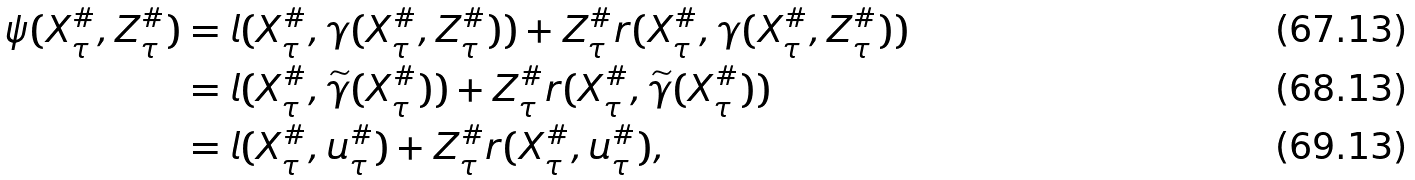<formula> <loc_0><loc_0><loc_500><loc_500>\psi ( X ^ { \# } _ { \tau } , Z ^ { \# } _ { \tau } ) & = l ( X ^ { \# } _ { \tau } , \gamma ( X ^ { \# } _ { \tau } , Z ^ { \# } _ { \tau } ) ) + Z ^ { \# } _ { \tau } r ( X ^ { \# } _ { \tau } , \gamma ( X ^ { \# } _ { \tau } , Z ^ { \# } _ { \tau } ) ) \\ & = l ( X ^ { \# } _ { \tau } , \widetilde { \gamma } ( X ^ { \# } _ { \tau } ) ) + Z ^ { \# } _ { \tau } r ( X ^ { \# } _ { \tau } , \widetilde { \gamma } ( X ^ { \# } _ { \tau } ) ) \\ & = l ( X ^ { \# } _ { \tau } , u ^ { \# } _ { \tau } ) + Z ^ { \# } _ { \tau } r ( X ^ { \# } _ { \tau } , u ^ { \# } _ { \tau } ) ,</formula> 